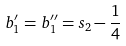Convert formula to latex. <formula><loc_0><loc_0><loc_500><loc_500>b _ { 1 } ^ { \prime } = b _ { 1 } ^ { { \prime } { \prime } } = s _ { 2 } - \frac { 1 } { 4 }</formula> 